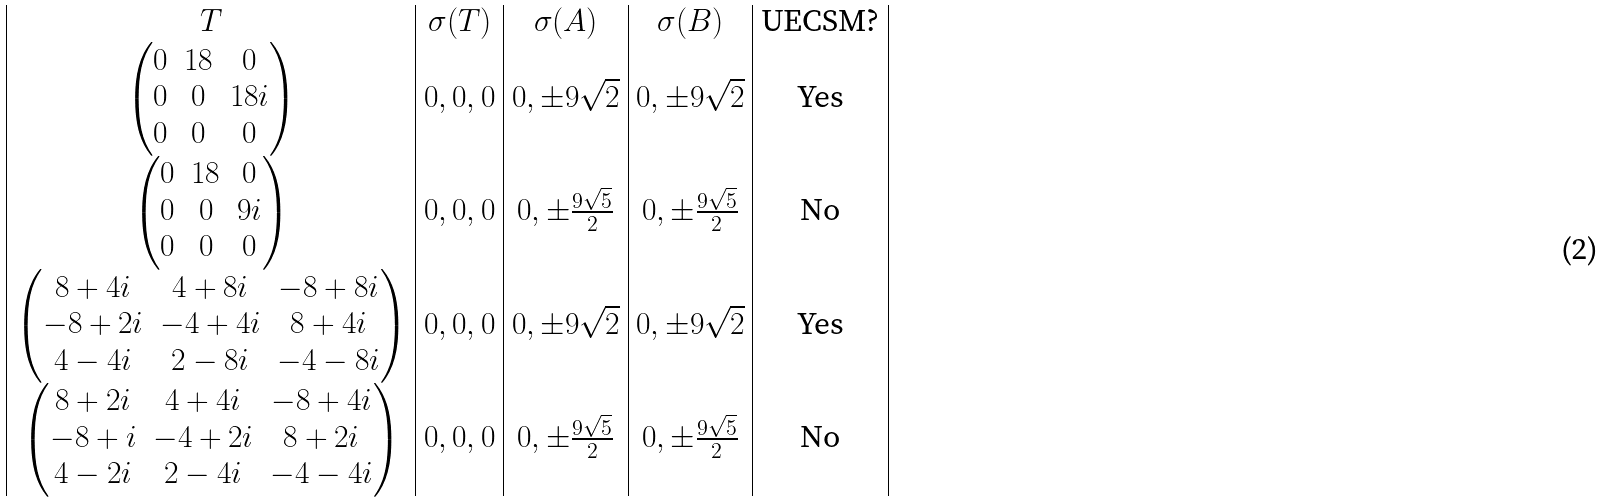Convert formula to latex. <formula><loc_0><loc_0><loc_500><loc_500>\begin{array} { | c | c | c | c | c | } T & \sigma ( T ) & \sigma ( A ) & \sigma ( B ) & \text {UECSM?} \\ \begin{pmatrix} 0 & 1 8 & 0 \\ 0 & 0 & 1 8 i \\ 0 & 0 & 0 \end{pmatrix} & 0 , 0 , 0 & 0 , \pm 9 \sqrt { 2 } & 0 , \pm 9 \sqrt { 2 } & \text {Yes} \\ \begin{pmatrix} 0 & 1 8 & 0 \\ 0 & 0 & 9 i \\ 0 & 0 & 0 \end{pmatrix} & 0 , 0 , 0 & 0 , \pm \frac { 9 \sqrt { 5 } } { 2 } & 0 , \pm \frac { 9 \sqrt { 5 } } { 2 } & \text {No} \\ \begin{pmatrix} 8 + 4 i & 4 + 8 i & - 8 + 8 i \\ - 8 + 2 i & - 4 + 4 i & 8 + 4 i \\ 4 - 4 i & 2 - 8 i & - 4 - 8 i \end{pmatrix} & 0 , 0 , 0 & 0 , \pm 9 \sqrt { 2 } & 0 , \pm 9 \sqrt { 2 } & \text {Yes} \\ \begin{pmatrix} 8 + 2 i & 4 + 4 i & - 8 + 4 i \\ - 8 + i & - 4 + 2 i & 8 + 2 i \\ 4 - 2 i & 2 - 4 i & - 4 - 4 i \end{pmatrix} & 0 , 0 , 0 & 0 , \pm \frac { 9 \sqrt { 5 } } { 2 } & 0 , \pm \frac { 9 \sqrt { 5 } } { 2 } & \text {No} \\ \end{array}</formula> 